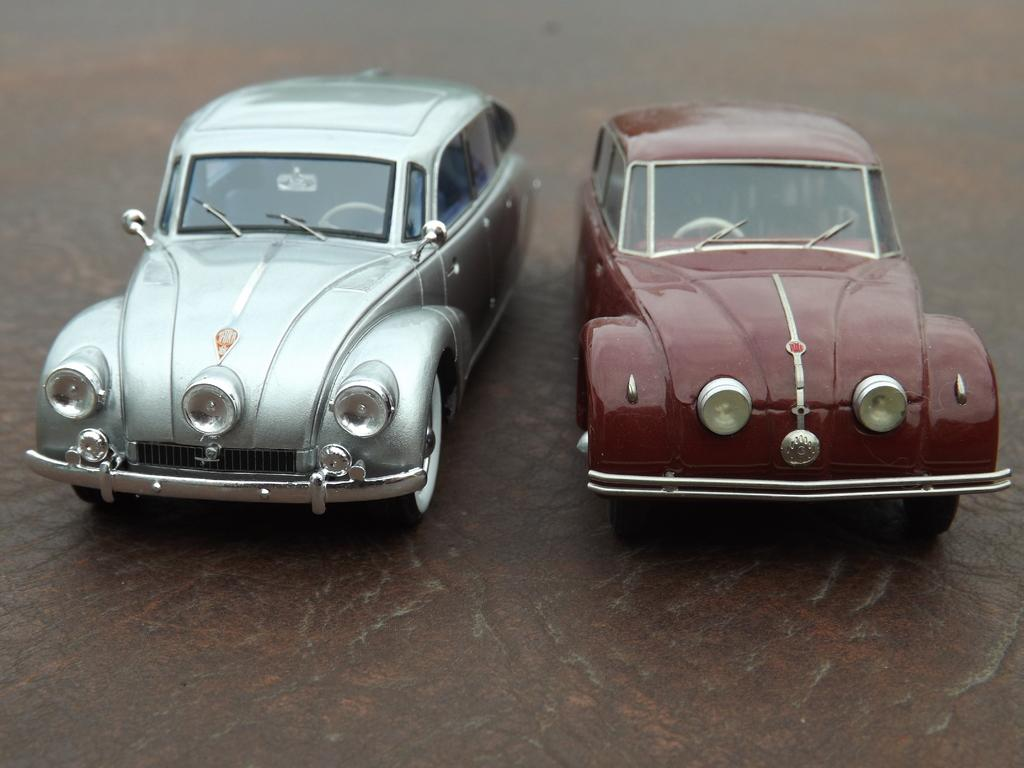How many cars are in the image? There are two cars in the image. What can you tell me about the location of the cars? The cars are on a surface. What type of band is performing in the image? There is no band present in the image; it only features two cars on a surface. 